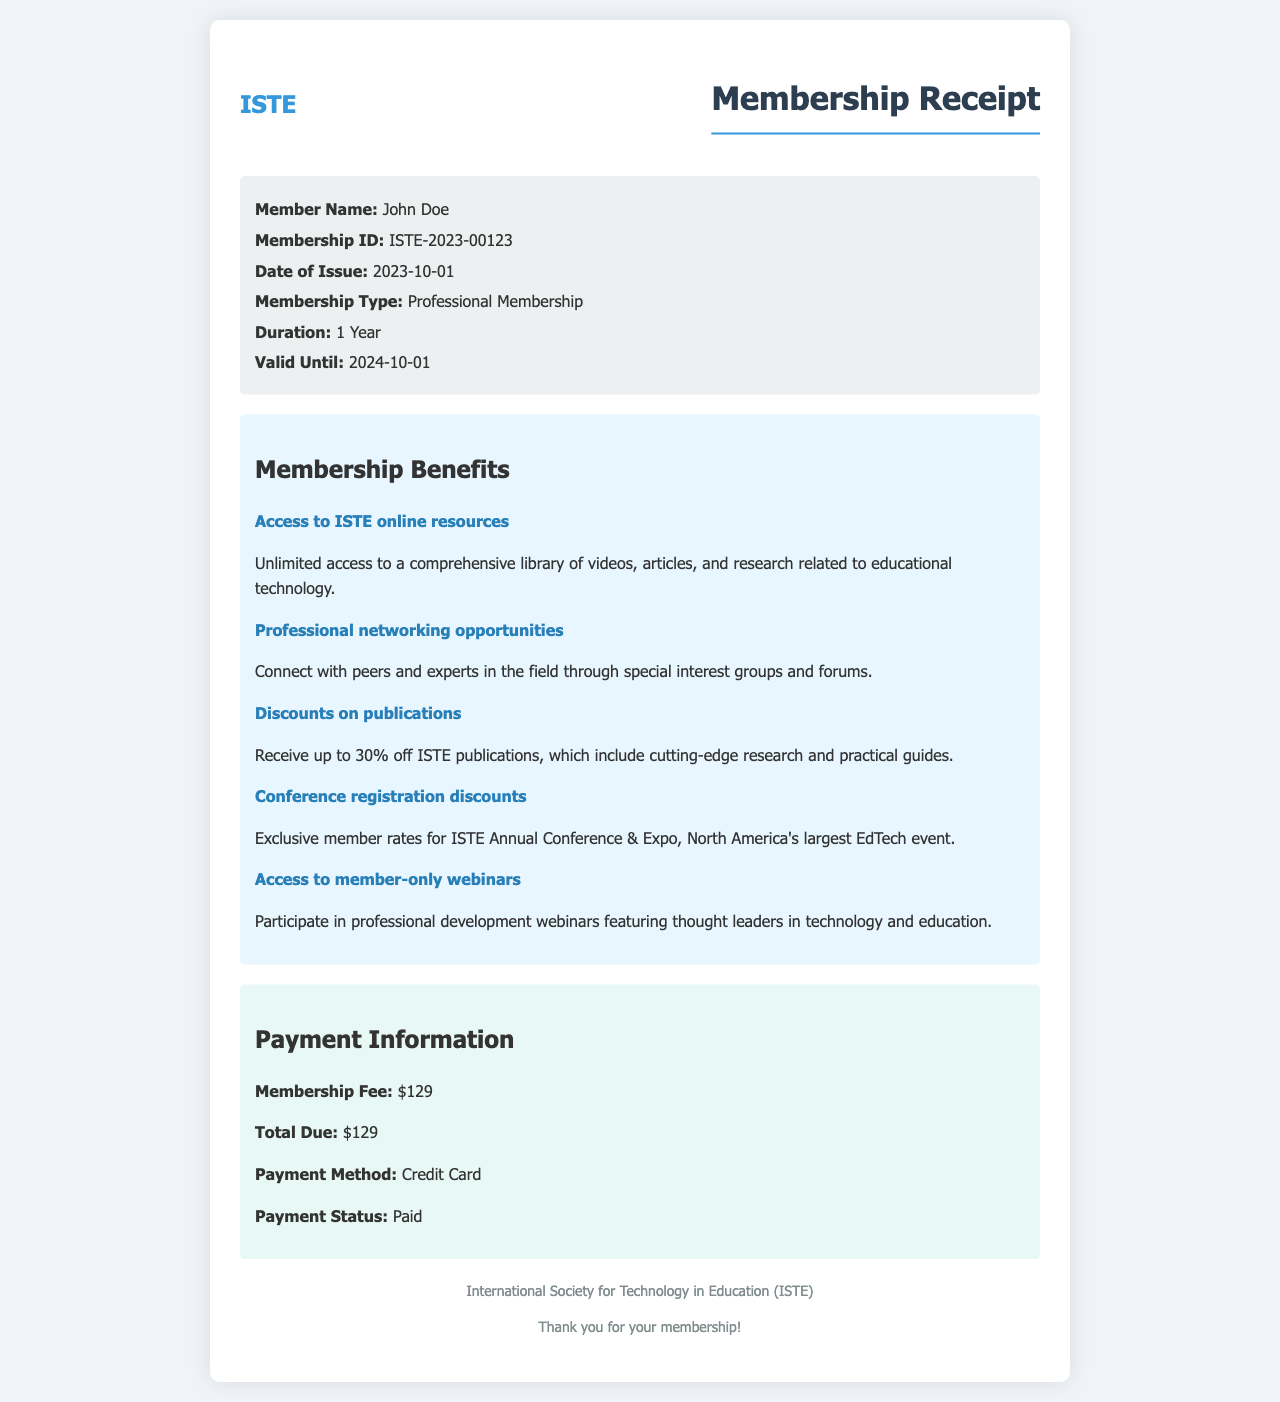What is the membership ID? The membership ID is a unique identifier found in the receipt, which is ISTE-2023-00123.
Answer: ISTE-2023-00123 What is the membership fee? The membership fee is explicitly mentioned in the payment information section of the receipt, which states $129.
Answer: $129 What are the valid until date? The valid until date indicates when the membership will expire, which is given as 2024-10-01.
Answer: 2024-10-01 How long is the membership duration? The duration of the membership, as specified in the receipt, is 1 Year.
Answer: 1 Year What is one benefit of membership? The membership benefits section lists several advantages; one example is the access to ISTE online resources.
Answer: Access to ISTE online resources What is the payment status? The document includes a payment status that indicates whether the payment has been completed or not, specified as Paid.
Answer: Paid What method was used for payment? The payment information section indicates the method utilized to pay the membership fee, which is Credit Card.
Answer: Credit Card What is the total due amount? The total due represents the total payment required, which is stated as $129 in the payment information section.
Answer: $129 What type of membership is this? The type of membership is explicitly stated in the receipt as Professional Membership.
Answer: Professional Membership 